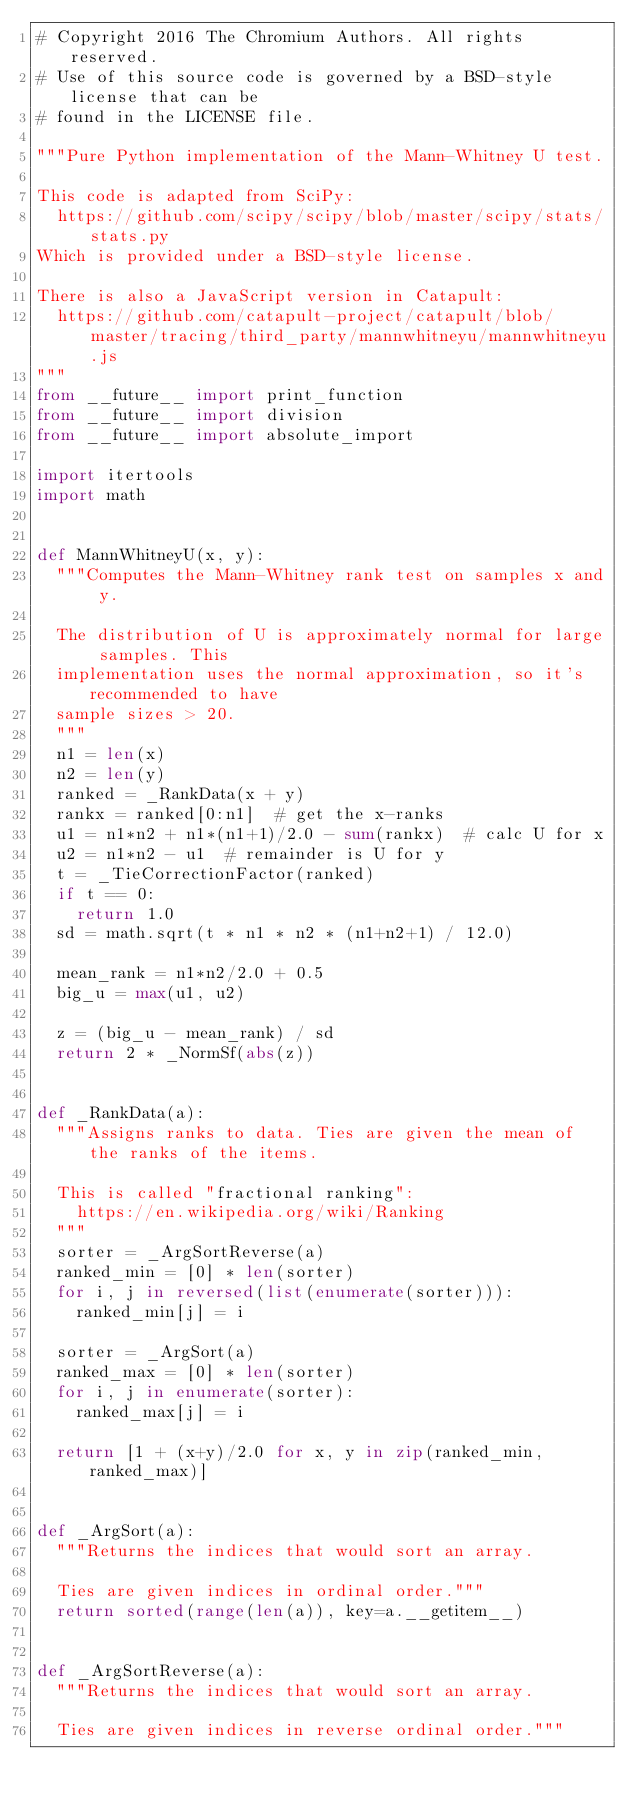Convert code to text. <code><loc_0><loc_0><loc_500><loc_500><_Python_># Copyright 2016 The Chromium Authors. All rights reserved.
# Use of this source code is governed by a BSD-style license that can be
# found in the LICENSE file.

"""Pure Python implementation of the Mann-Whitney U test.

This code is adapted from SciPy:
  https://github.com/scipy/scipy/blob/master/scipy/stats/stats.py
Which is provided under a BSD-style license.

There is also a JavaScript version in Catapult:
  https://github.com/catapult-project/catapult/blob/master/tracing/third_party/mannwhitneyu/mannwhitneyu.js
"""
from __future__ import print_function
from __future__ import division
from __future__ import absolute_import

import itertools
import math


def MannWhitneyU(x, y):
  """Computes the Mann-Whitney rank test on samples x and y.

  The distribution of U is approximately normal for large samples. This
  implementation uses the normal approximation, so it's recommended to have
  sample sizes > 20.
  """
  n1 = len(x)
  n2 = len(y)
  ranked = _RankData(x + y)
  rankx = ranked[0:n1]  # get the x-ranks
  u1 = n1*n2 + n1*(n1+1)/2.0 - sum(rankx)  # calc U for x
  u2 = n1*n2 - u1  # remainder is U for y
  t = _TieCorrectionFactor(ranked)
  if t == 0:
    return 1.0
  sd = math.sqrt(t * n1 * n2 * (n1+n2+1) / 12.0)

  mean_rank = n1*n2/2.0 + 0.5
  big_u = max(u1, u2)

  z = (big_u - mean_rank) / sd
  return 2 * _NormSf(abs(z))


def _RankData(a):
  """Assigns ranks to data. Ties are given the mean of the ranks of the items.

  This is called "fractional ranking":
    https://en.wikipedia.org/wiki/Ranking
  """
  sorter = _ArgSortReverse(a)
  ranked_min = [0] * len(sorter)
  for i, j in reversed(list(enumerate(sorter))):
    ranked_min[j] = i

  sorter = _ArgSort(a)
  ranked_max = [0] * len(sorter)
  for i, j in enumerate(sorter):
    ranked_max[j] = i

  return [1 + (x+y)/2.0 for x, y in zip(ranked_min, ranked_max)]


def _ArgSort(a):
  """Returns the indices that would sort an array.

  Ties are given indices in ordinal order."""
  return sorted(range(len(a)), key=a.__getitem__)


def _ArgSortReverse(a):
  """Returns the indices that would sort an array.

  Ties are given indices in reverse ordinal order."""</code> 